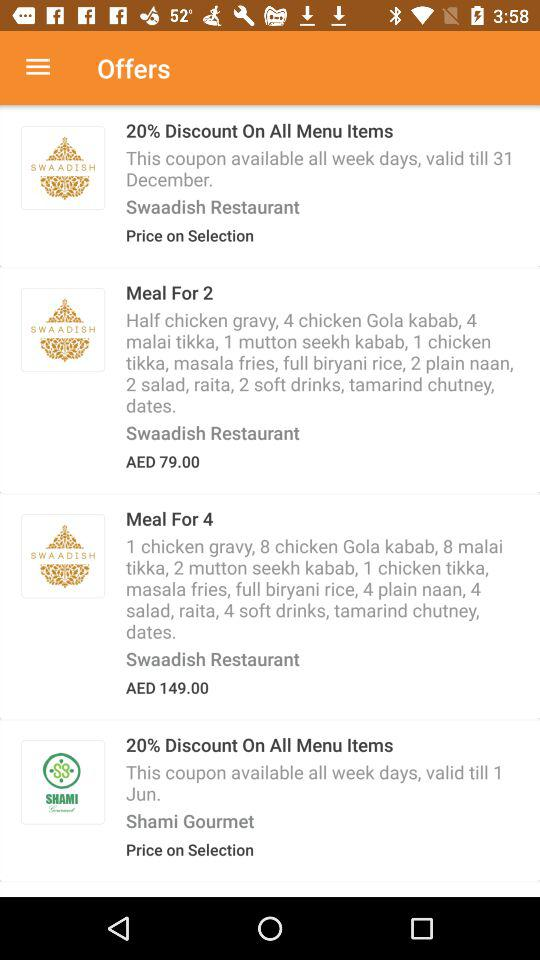How much more does the meal for 4 cost than the meal for 2?
Answer the question using a single word or phrase. AED 70.00 